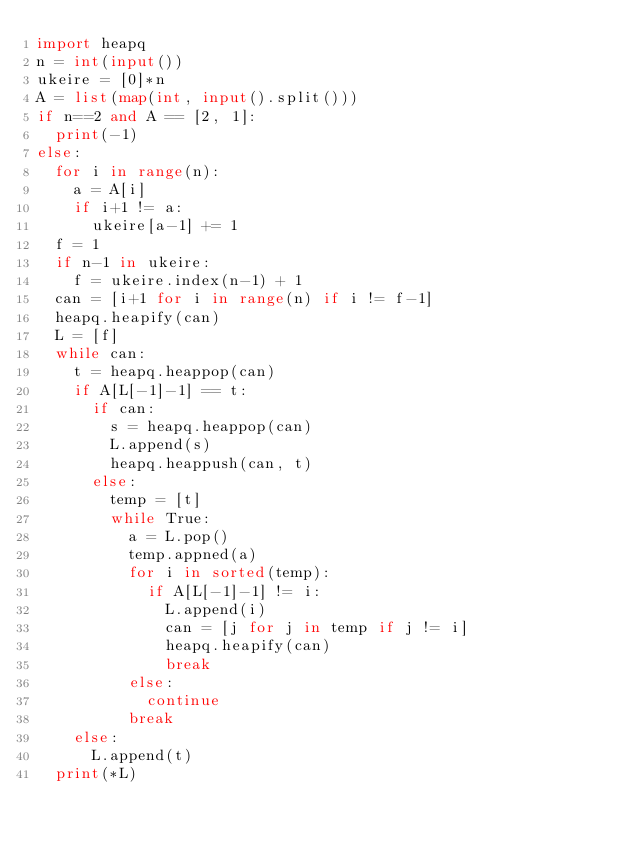<code> <loc_0><loc_0><loc_500><loc_500><_Python_>import heapq
n = int(input())
ukeire = [0]*n
A = list(map(int, input().split()))
if n==2 and A == [2, 1]:
  print(-1)
else:
  for i in range(n):
    a = A[i]
    if i+1 != a:
      ukeire[a-1] += 1
  f = 1
  if n-1 in ukeire:
    f = ukeire.index(n-1) + 1
  can = [i+1 for i in range(n) if i != f-1]
  heapq.heapify(can)
  L = [f]
  while can:
    t = heapq.heappop(can)
    if A[L[-1]-1] == t:
      if can:
        s = heapq.heappop(can)
        L.append(s)
        heapq.heappush(can, t)
      else:
        temp = [t]
        while True:
          a = L.pop()
          temp.appned(a)
          for i in sorted(temp):
            if A[L[-1]-1] != i:
              L.append(i)
              can = [j for j in temp if j != i]
              heapq.heapify(can)
              break
          else:
            continue
          break
    else:
      L.append(t)
  print(*L)</code> 